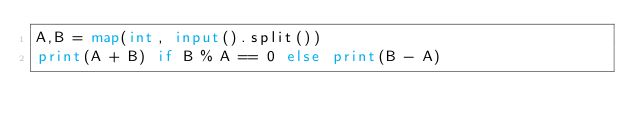<code> <loc_0><loc_0><loc_500><loc_500><_Python_>A,B = map(int, input().split())
print(A + B) if B % A == 0 else print(B - A)</code> 